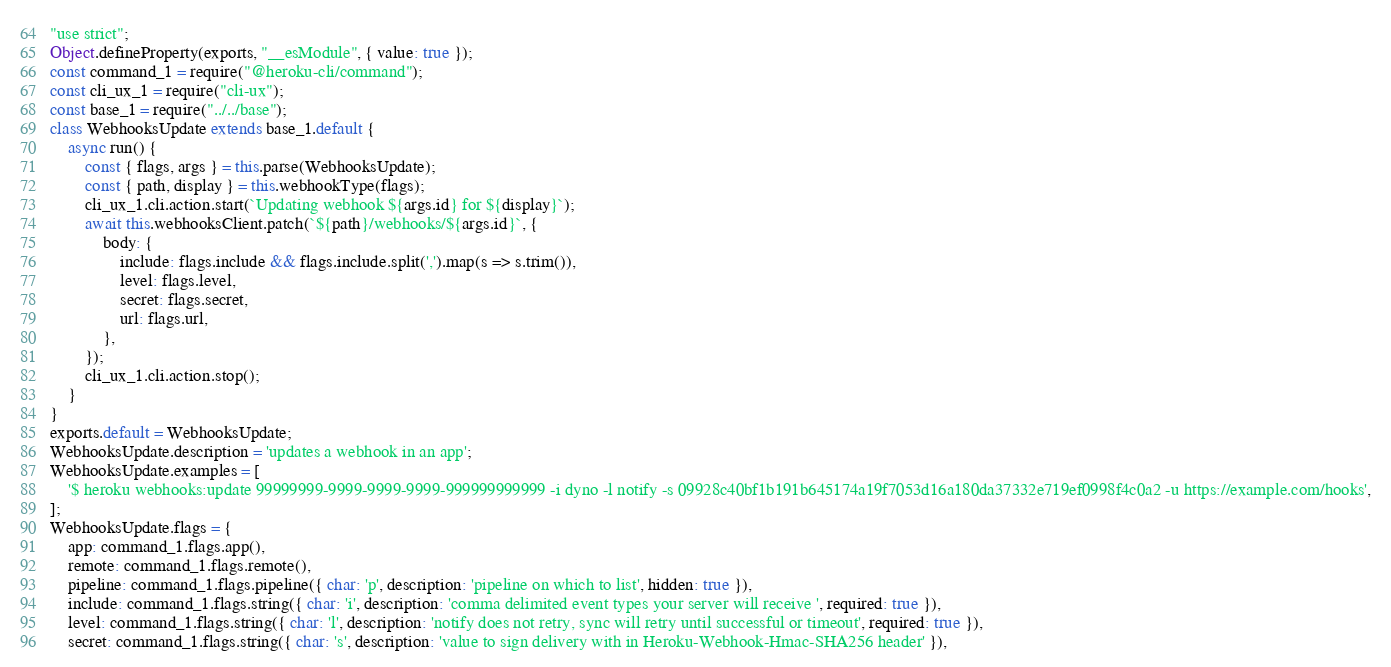<code> <loc_0><loc_0><loc_500><loc_500><_JavaScript_>"use strict";
Object.defineProperty(exports, "__esModule", { value: true });
const command_1 = require("@heroku-cli/command");
const cli_ux_1 = require("cli-ux");
const base_1 = require("../../base");
class WebhooksUpdate extends base_1.default {
    async run() {
        const { flags, args } = this.parse(WebhooksUpdate);
        const { path, display } = this.webhookType(flags);
        cli_ux_1.cli.action.start(`Updating webhook ${args.id} for ${display}`);
        await this.webhooksClient.patch(`${path}/webhooks/${args.id}`, {
            body: {
                include: flags.include && flags.include.split(',').map(s => s.trim()),
                level: flags.level,
                secret: flags.secret,
                url: flags.url,
            },
        });
        cli_ux_1.cli.action.stop();
    }
}
exports.default = WebhooksUpdate;
WebhooksUpdate.description = 'updates a webhook in an app';
WebhooksUpdate.examples = [
    '$ heroku webhooks:update 99999999-9999-9999-9999-999999999999 -i dyno -l notify -s 09928c40bf1b191b645174a19f7053d16a180da37332e719ef0998f4c0a2 -u https://example.com/hooks',
];
WebhooksUpdate.flags = {
    app: command_1.flags.app(),
    remote: command_1.flags.remote(),
    pipeline: command_1.flags.pipeline({ char: 'p', description: 'pipeline on which to list', hidden: true }),
    include: command_1.flags.string({ char: 'i', description: 'comma delimited event types your server will receive ', required: true }),
    level: command_1.flags.string({ char: 'l', description: 'notify does not retry, sync will retry until successful or timeout', required: true }),
    secret: command_1.flags.string({ char: 's', description: 'value to sign delivery with in Heroku-Webhook-Hmac-SHA256 header' }),</code> 